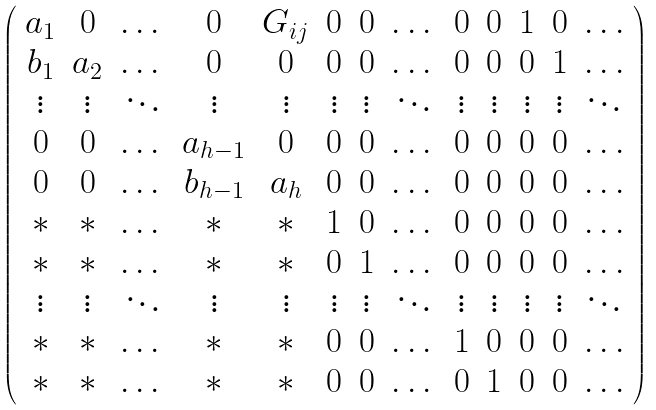<formula> <loc_0><loc_0><loc_500><loc_500>\left ( \begin{array} { c c c c c c c c c c c c c } a _ { 1 } & 0 & \dots & 0 & G _ { i j } & 0 & 0 & \dots & 0 & 0 & 1 & 0 & \dots \\ b _ { 1 } & a _ { 2 } & \dots & 0 & 0 & 0 & 0 & \dots & 0 & 0 & 0 & 1 & \dots \\ \vdots & \vdots & \ddots & \vdots & \vdots & \vdots & \vdots & \ddots & \vdots & \vdots & \vdots & \vdots & \ddots \\ 0 & 0 & \dots & a _ { h - 1 } & 0 & 0 & 0 & \dots & 0 & 0 & 0 & 0 & \dots \\ 0 & 0 & \dots & b _ { h - 1 } & a _ { h } & 0 & 0 & \dots & 0 & 0 & 0 & 0 & \dots \\ * & * & \dots & * & * & 1 & 0 & \dots & 0 & 0 & 0 & 0 & \dots \\ * & * & \dots & * & * & 0 & 1 & \dots & 0 & 0 & 0 & 0 & \dots \\ \vdots & \vdots & \ddots & \vdots & \vdots & \vdots & \vdots & \ddots & \vdots & \vdots & \vdots & \vdots & \ddots \\ * & * & \dots & * & * & 0 & 0 & \dots & 1 & 0 & 0 & 0 & \dots \\ * & * & \dots & * & * & 0 & 0 & \dots & 0 & 1 & 0 & 0 & \dots \end{array} \right )</formula> 